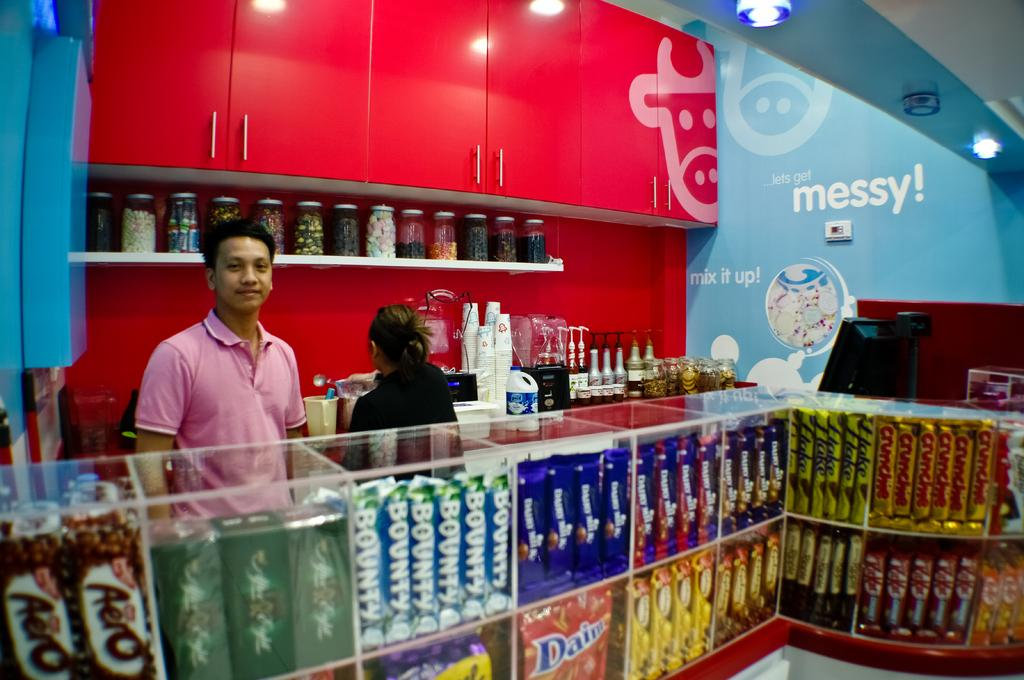<image>
Create a compact narrative representing the image presented. A store's walls carry messages like Mix It Up! and Messy! 